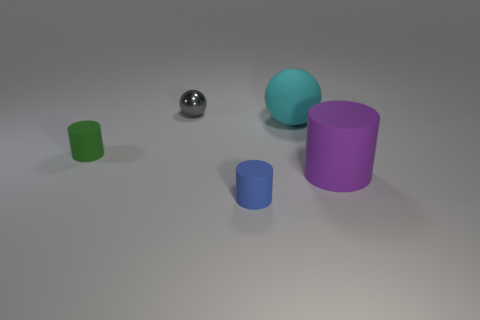Add 4 tiny green matte things. How many objects exist? 9 Subtract all balls. How many objects are left? 3 Add 5 large red matte balls. How many large red matte balls exist? 5 Subtract 0 cyan cubes. How many objects are left? 5 Subtract all gray rubber cylinders. Subtract all blue rubber cylinders. How many objects are left? 4 Add 3 small balls. How many small balls are left? 4 